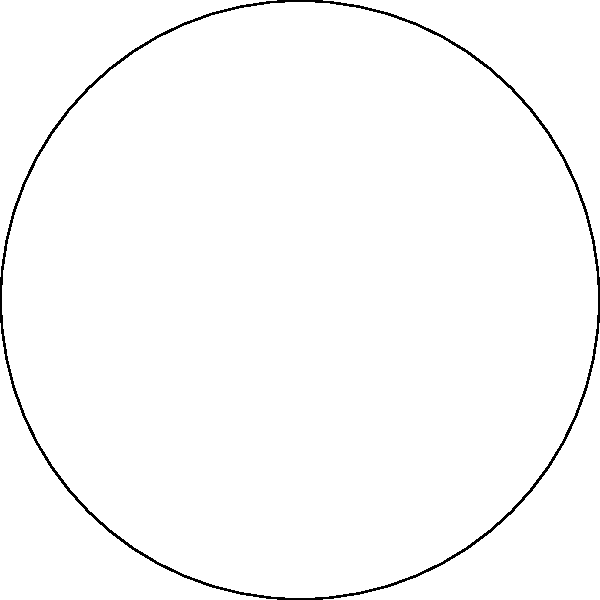In a circular garden with a radius of 10 meters, different pollinators occupy specific sectors based on their preferred flower types. Butterflies occupy a 120° sector, bees occupy a 90° sector, and hummingbirds occupy the remaining area. What is the difference in square meters between the areas occupied by butterflies and hummingbirds? Let's approach this step-by-step:

1) First, we need to calculate the total area of the circular garden:
   $A_{total} = \pi r^2 = \pi (10)^2 = 100\pi$ m²

2) Now, let's calculate the areas for each pollinator:

   For butterflies (120°):
   $A_{butterflies} = \frac{120}{360} \times 100\pi = \frac{1}{3} \times 100\pi = \frac{100\pi}{3}$ m²

   For bees (90°):
   $A_{bees} = \frac{90}{360} \times 100\pi = \frac{1}{4} \times 100\pi = 25\pi$ m²

   For hummingbirds (remaining 150°):
   $A_{hummingbirds} = \frac{150}{360} \times 100\pi = \frac{5}{12} \times 100\pi = \frac{125\pi}{3}$ m²

3) Now, we need to find the difference between the areas of butterflies and hummingbirds:

   $Difference = A_{hummingbirds} - A_{butterflies}$
   $= \frac{125\pi}{3} - \frac{100\pi}{3}$
   $= \frac{25\pi}{3}$ m²

4) To get the final answer in square meters, we can approximate π to 3.14159:

   $\frac{25 \times 3.14159}{3} \approx 26.18$ m²

Therefore, the area occupied by hummingbirds is approximately 26.18 square meters larger than the area occupied by butterflies.
Answer: 26.18 m² 